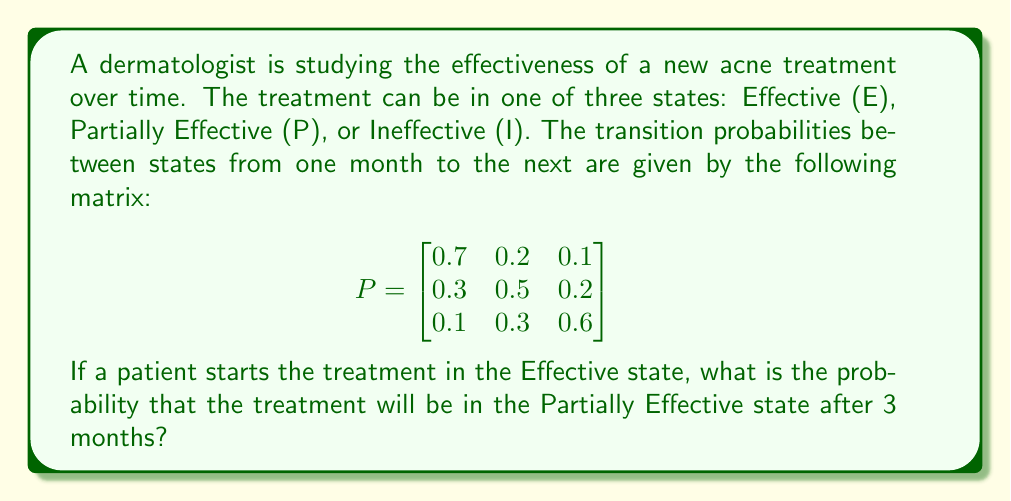Give your solution to this math problem. To solve this problem, we need to use the Markov chain properties and matrix multiplication. Let's approach this step-by-step:

1) The initial state vector is $v_0 = [1, 0, 0]$, representing that we start in the Effective state.

2) To find the state after 3 months, we need to multiply the initial state vector by the transition matrix three times:

   $v_3 = v_0 \cdot P^3$

3) Let's calculate $P^2$ first:

   $$P^2 = P \cdot P = \begin{bmatrix}
   0.56 & 0.28 & 0.16 \\
   0.37 & 0.41 & 0.22 \\
   0.22 & 0.33 & 0.45
   \end{bmatrix}$$

4) Now let's calculate $P^3$:

   $$P^3 = P^2 \cdot P = \begin{bmatrix}
   0.497 & 0.308 & 0.195 \\
   0.391 & 0.371 & 0.238 \\
   0.289 & 0.339 & 0.372
   \end{bmatrix}$$

5) Now we multiply $v_0$ by $P^3$:

   $v_3 = [1, 0, 0] \cdot \begin{bmatrix}
   0.497 & 0.308 & 0.195 \\
   0.391 & 0.371 & 0.238 \\
   0.289 & 0.339 & 0.372
   \end{bmatrix} = [0.497, 0.308, 0.195]$

6) The probability of being in the Partially Effective state after 3 months is the second element of this vector, which is 0.308 or 30.8%.
Answer: 0.308 